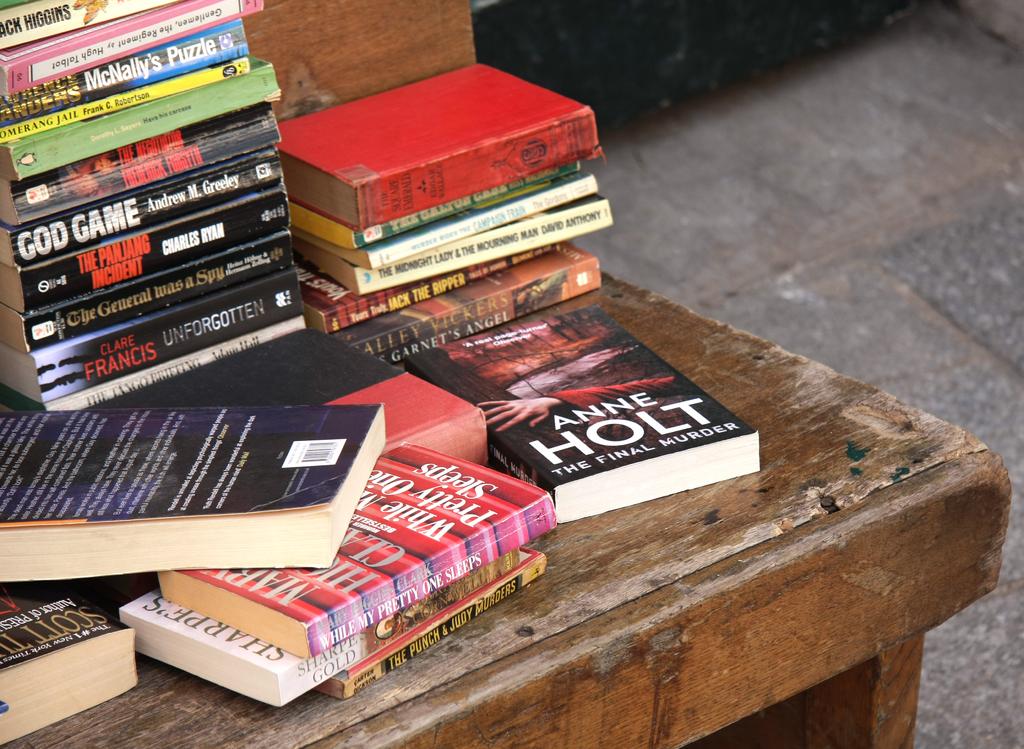Who is the author's name shown on the book?
Make the answer very short. Anne holt. Who is it the author of god game?
Your answer should be compact. Andrew m. greeley. 